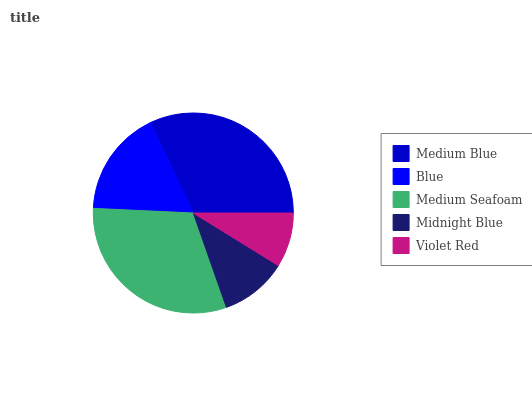Is Violet Red the minimum?
Answer yes or no. Yes. Is Medium Blue the maximum?
Answer yes or no. Yes. Is Blue the minimum?
Answer yes or no. No. Is Blue the maximum?
Answer yes or no. No. Is Medium Blue greater than Blue?
Answer yes or no. Yes. Is Blue less than Medium Blue?
Answer yes or no. Yes. Is Blue greater than Medium Blue?
Answer yes or no. No. Is Medium Blue less than Blue?
Answer yes or no. No. Is Blue the high median?
Answer yes or no. Yes. Is Blue the low median?
Answer yes or no. Yes. Is Medium Blue the high median?
Answer yes or no. No. Is Medium Blue the low median?
Answer yes or no. No. 